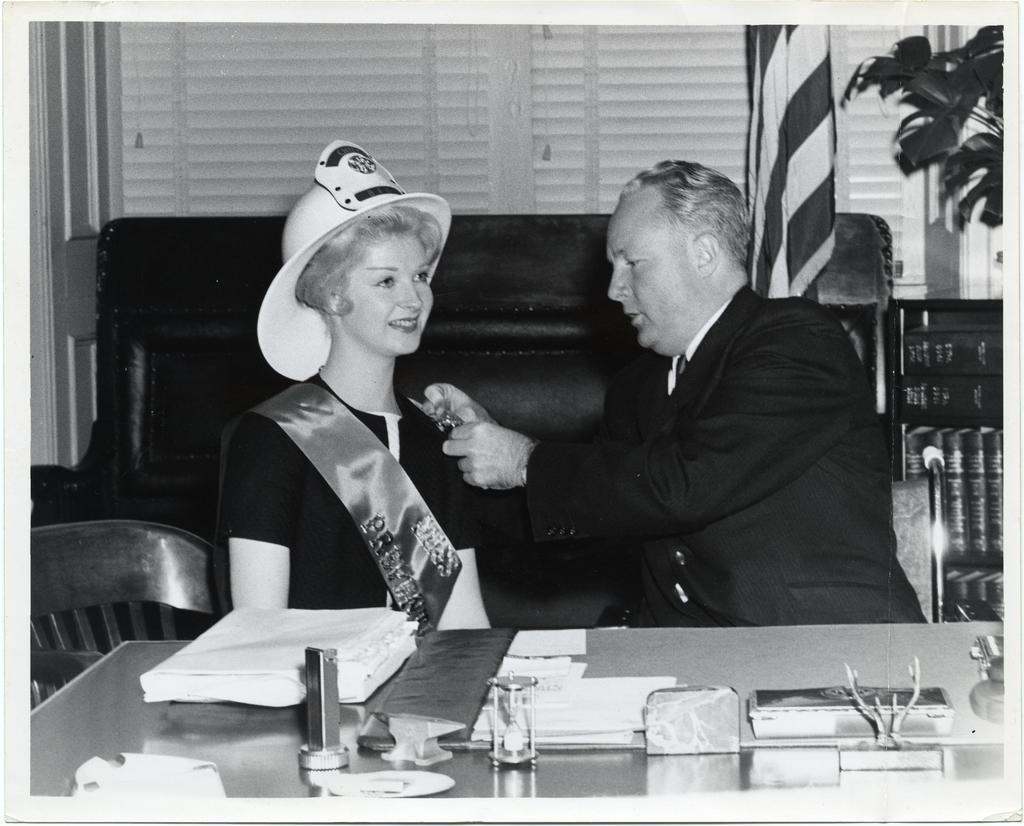In one or two sentences, can you explain what this image depicts? This is a black and white picture. Here we can see a man and a woman sitting on a sofa in front of a table and on the table we can see a minute sand timer. These are chairs. This is a flag. Here we can see a plant. This man is putting a badge to a woman. She wore a cap. 